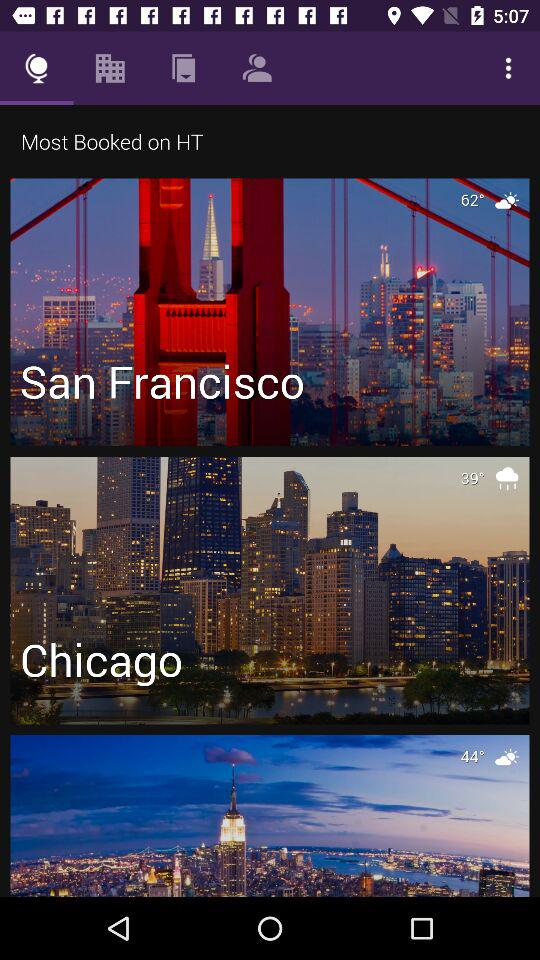At which location is the temperature 39 degrees? The location is Chicago. 